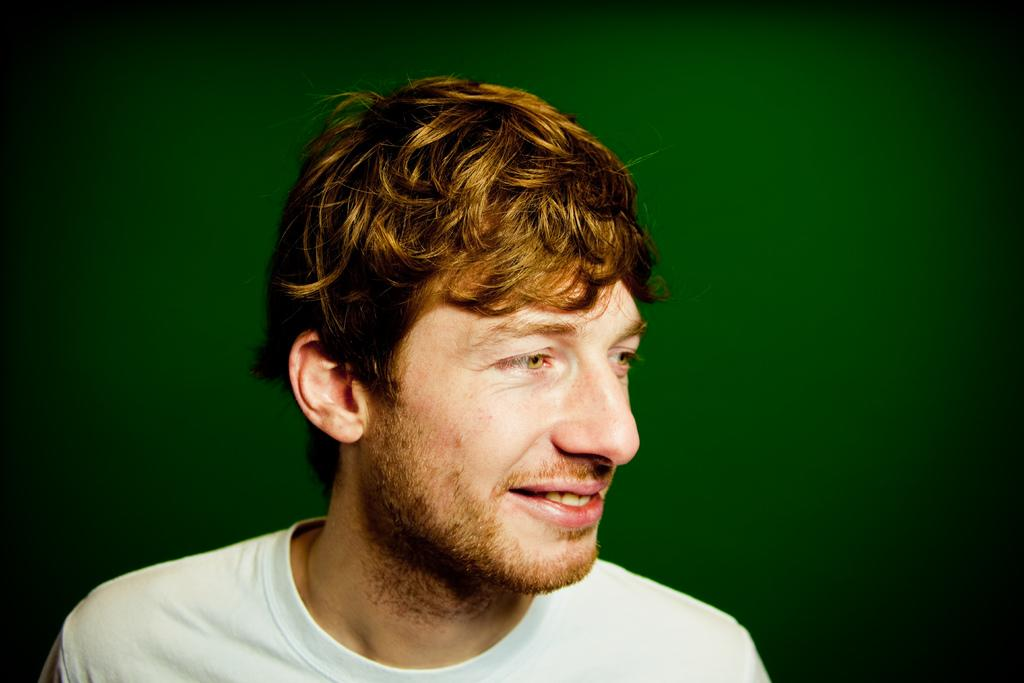What is the main subject in the foreground of the image? There is a man in the foreground of the image. What is the man doing in the image? The man is laughing. What type of bed is visible in the image? There is no bed present in the image; it only features a man in the foreground. 